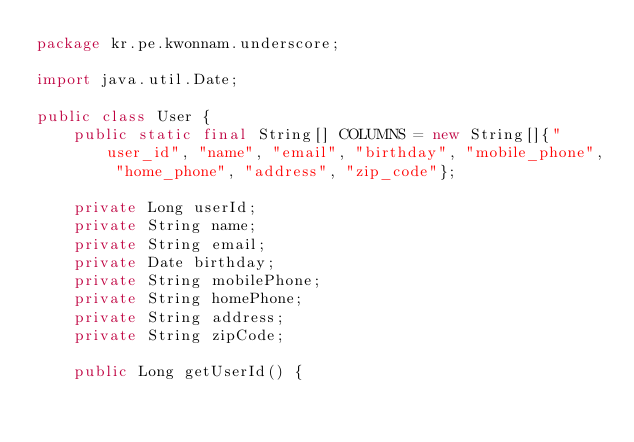<code> <loc_0><loc_0><loc_500><loc_500><_Java_>package kr.pe.kwonnam.underscore;

import java.util.Date;

public class User {
    public static final String[] COLUMNS = new String[]{"user_id", "name", "email", "birthday", "mobile_phone", "home_phone", "address", "zip_code"};

    private Long userId;
    private String name;
    private String email;
    private Date birthday;
    private String mobilePhone;
    private String homePhone;
    private String address;
    private String zipCode;

    public Long getUserId() {</code> 